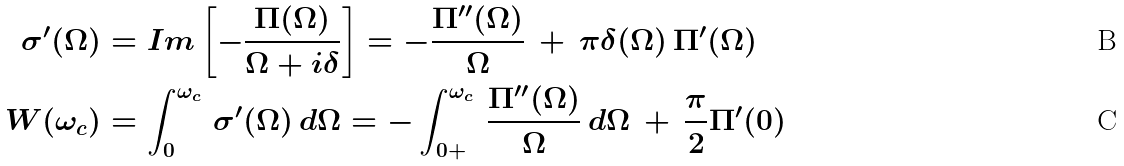Convert formula to latex. <formula><loc_0><loc_0><loc_500><loc_500>\sigma ^ { \prime } ( \Omega ) & = I m \left [ - \frac { \Pi ( \Omega ) } { \Omega + i \delta } \right ] = - \frac { \Pi ^ { \prime \prime } ( \Omega ) } { \Omega } \, + \, \pi \delta ( \Omega ) \, \Pi ^ { \prime } ( \Omega ) \\ W ( \omega _ { c } ) & = \int ^ { \omega _ { c } } _ { 0 } \, \sigma ^ { \prime } ( \Omega ) \, d \Omega = - \int ^ { \omega _ { c } } _ { 0 + } \, \frac { \Pi ^ { \prime \prime } ( \Omega ) } { \Omega } \, d \Omega \, + \, \frac { \pi } { 2 } \Pi ^ { \prime } ( 0 )</formula> 